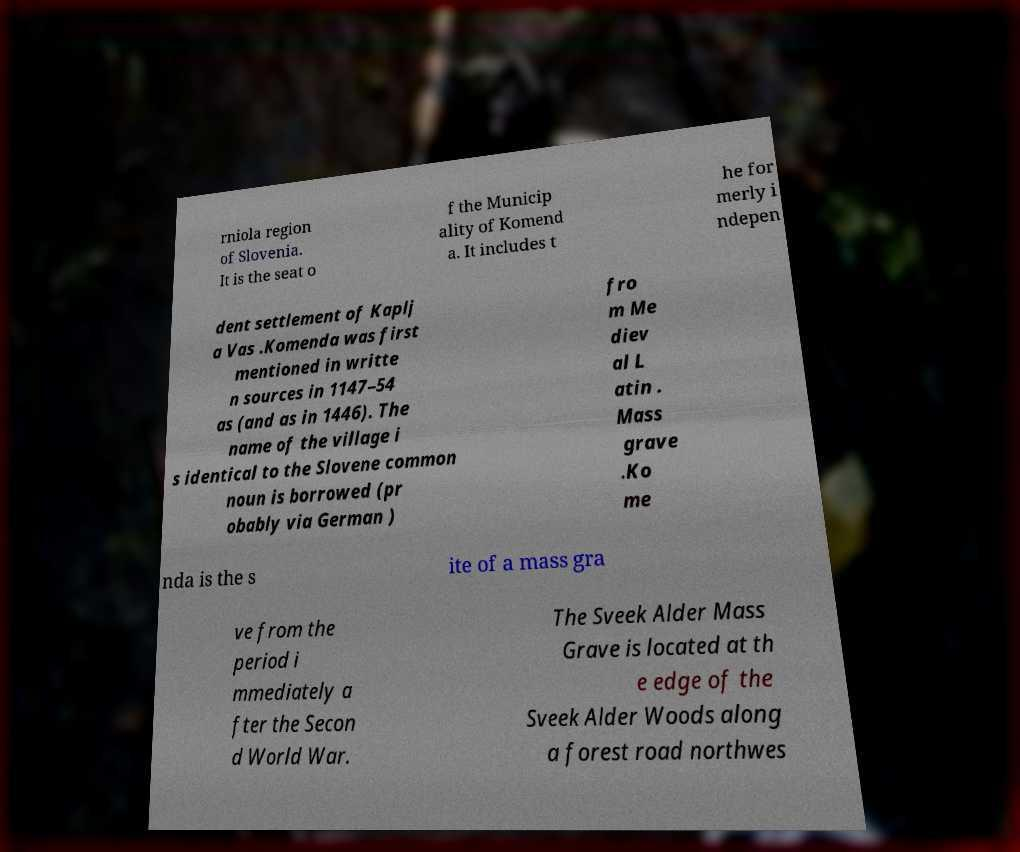What messages or text are displayed in this image? I need them in a readable, typed format. rniola region of Slovenia. It is the seat o f the Municip ality of Komend a. It includes t he for merly i ndepen dent settlement of Kaplj a Vas .Komenda was first mentioned in writte n sources in 1147–54 as (and as in 1446). The name of the village i s identical to the Slovene common noun is borrowed (pr obably via German ) fro m Me diev al L atin . Mass grave .Ko me nda is the s ite of a mass gra ve from the period i mmediately a fter the Secon d World War. The Sveek Alder Mass Grave is located at th e edge of the Sveek Alder Woods along a forest road northwes 